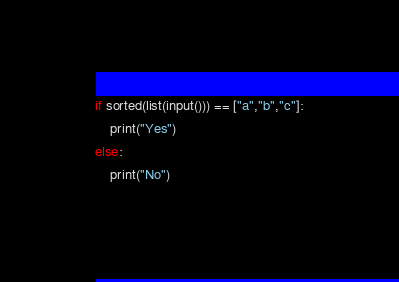Convert code to text. <code><loc_0><loc_0><loc_500><loc_500><_Python_>if sorted(list(input())) == ["a","b","c"]:
    print("Yes")
else:
    print("No")</code> 